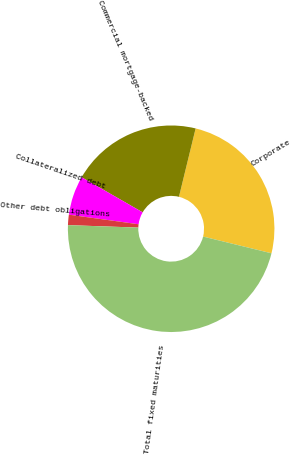Convert chart to OTSL. <chart><loc_0><loc_0><loc_500><loc_500><pie_chart><fcel>Corporate<fcel>Commercial mortgage-backed<fcel>Collateralized debt<fcel>Other debt obligations<fcel>Total fixed maturities<nl><fcel>25.01%<fcel>20.5%<fcel>6.13%<fcel>1.62%<fcel>46.74%<nl></chart> 